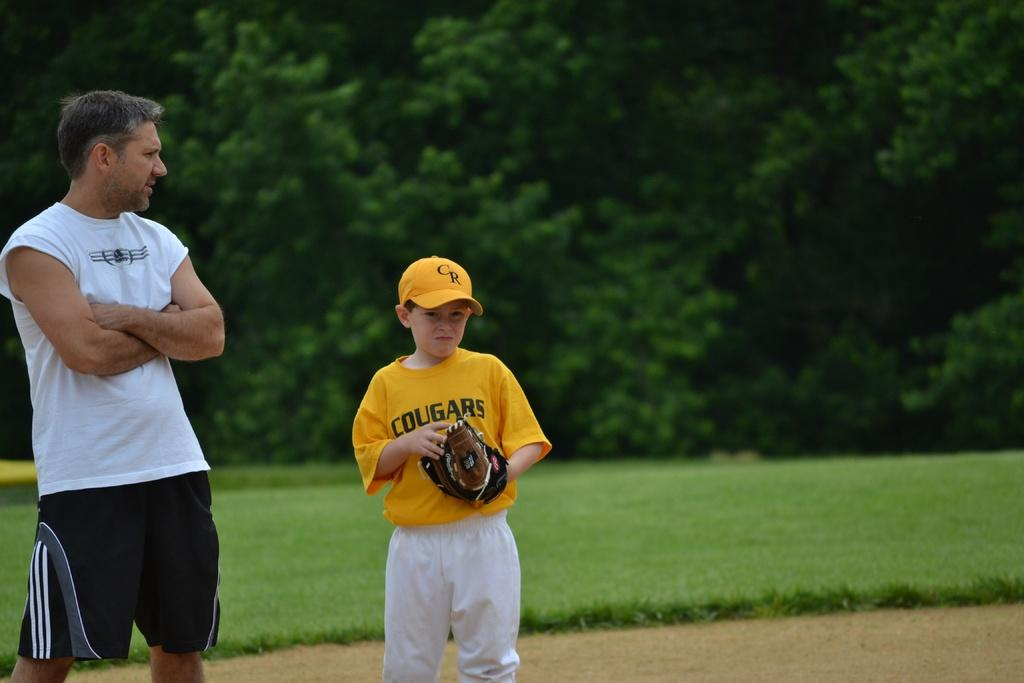<image>
Summarize the visual content of the image. A young boy is wearing a yellow tee shirt which has the word Cougars on it. 